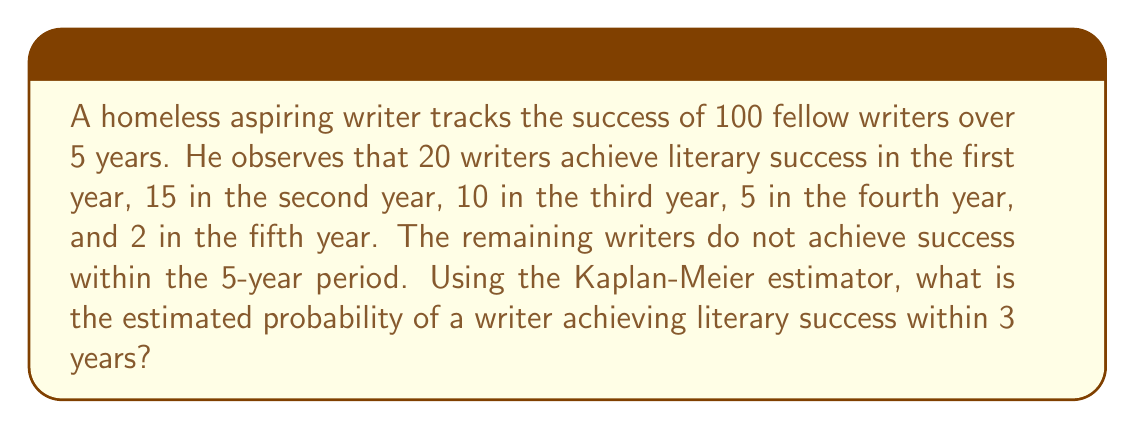Provide a solution to this math problem. To solve this problem using the Kaplan-Meier estimator, we'll follow these steps:

1. Calculate the number of writers at risk at the beginning of each year.
2. Calculate the survival probability for each year.
3. Compute the cumulative survival probability up to 3 years.
4. Subtract the cumulative survival probability from 1 to get the probability of success.

Step 1: Calculate the number at risk:
Year 1: 100
Year 2: 100 - 20 = 80
Year 3: 80 - 15 = 65

Step 2: Calculate survival probability for each year:
Year 1: $S_1 = \frac{100 - 20}{100} = 0.80$
Year 2: $S_2 = \frac{80 - 15}{80} = 0.8125$
Year 3: $S_3 = \frac{65 - 10}{65} = 0.8462$

Step 3: Compute cumulative survival probability up to 3 years:
$S(3) = S_1 \times S_2 \times S_3 = 0.80 \times 0.8125 \times 0.8462 = 0.5503$

Step 4: Subtract from 1 to get the probability of success:
$P(\text{success within 3 years}) = 1 - S(3) = 1 - 0.5503 = 0.4497$

Therefore, the estimated probability of a writer achieving literary success within 3 years is approximately 0.4497 or 44.97%.
Answer: 0.4497 